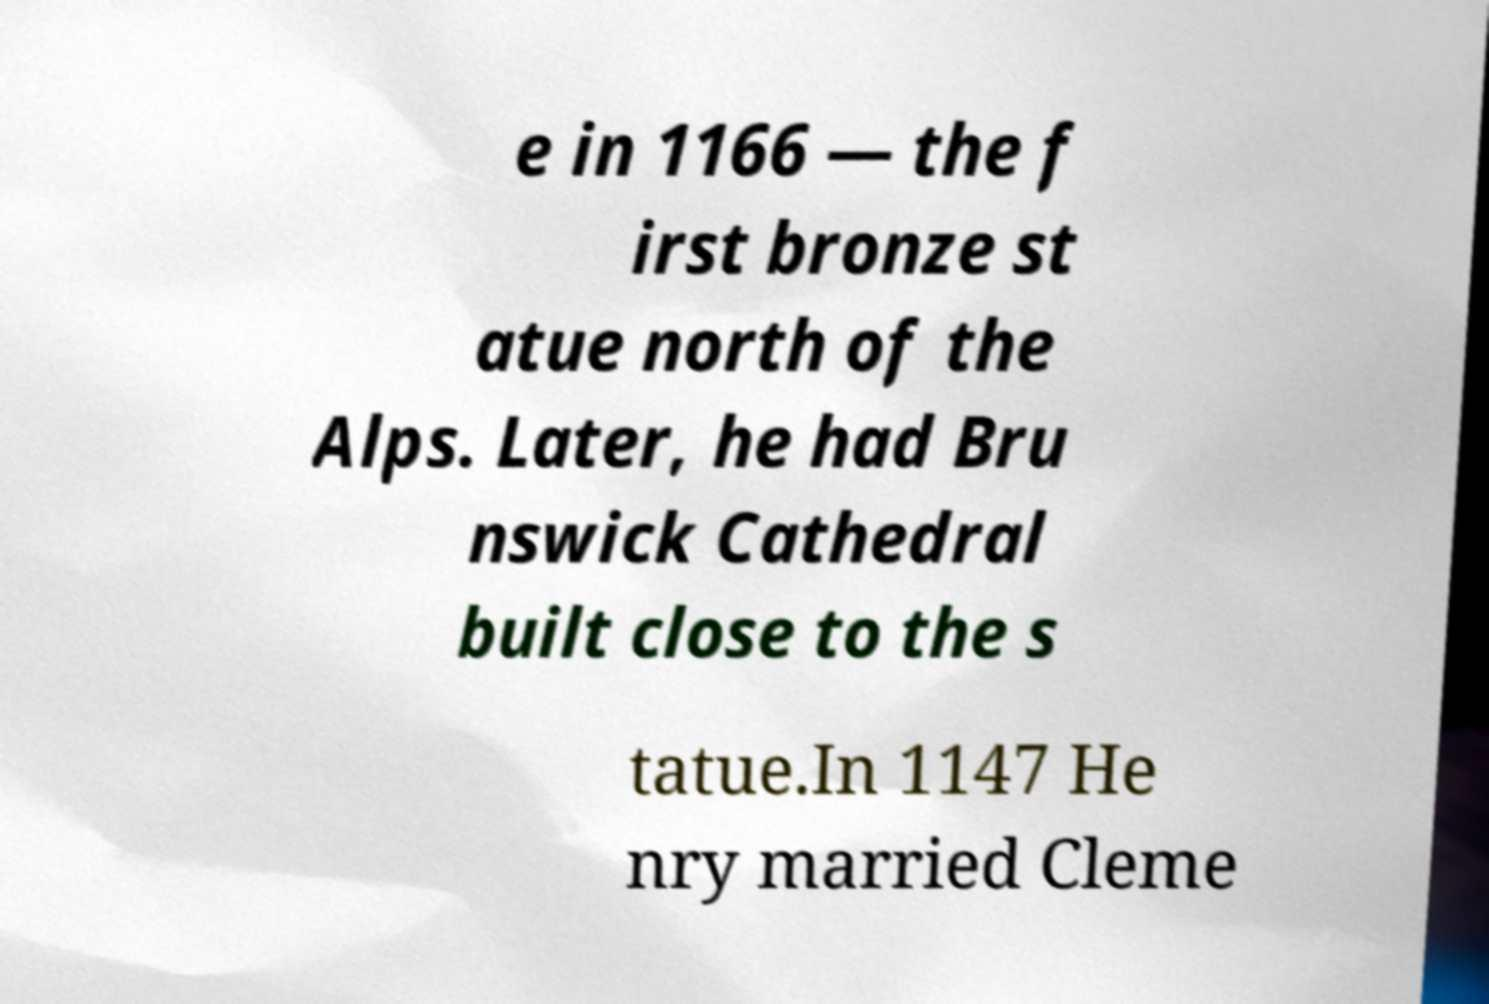Could you assist in decoding the text presented in this image and type it out clearly? e in 1166 — the f irst bronze st atue north of the Alps. Later, he had Bru nswick Cathedral built close to the s tatue.In 1147 He nry married Cleme 